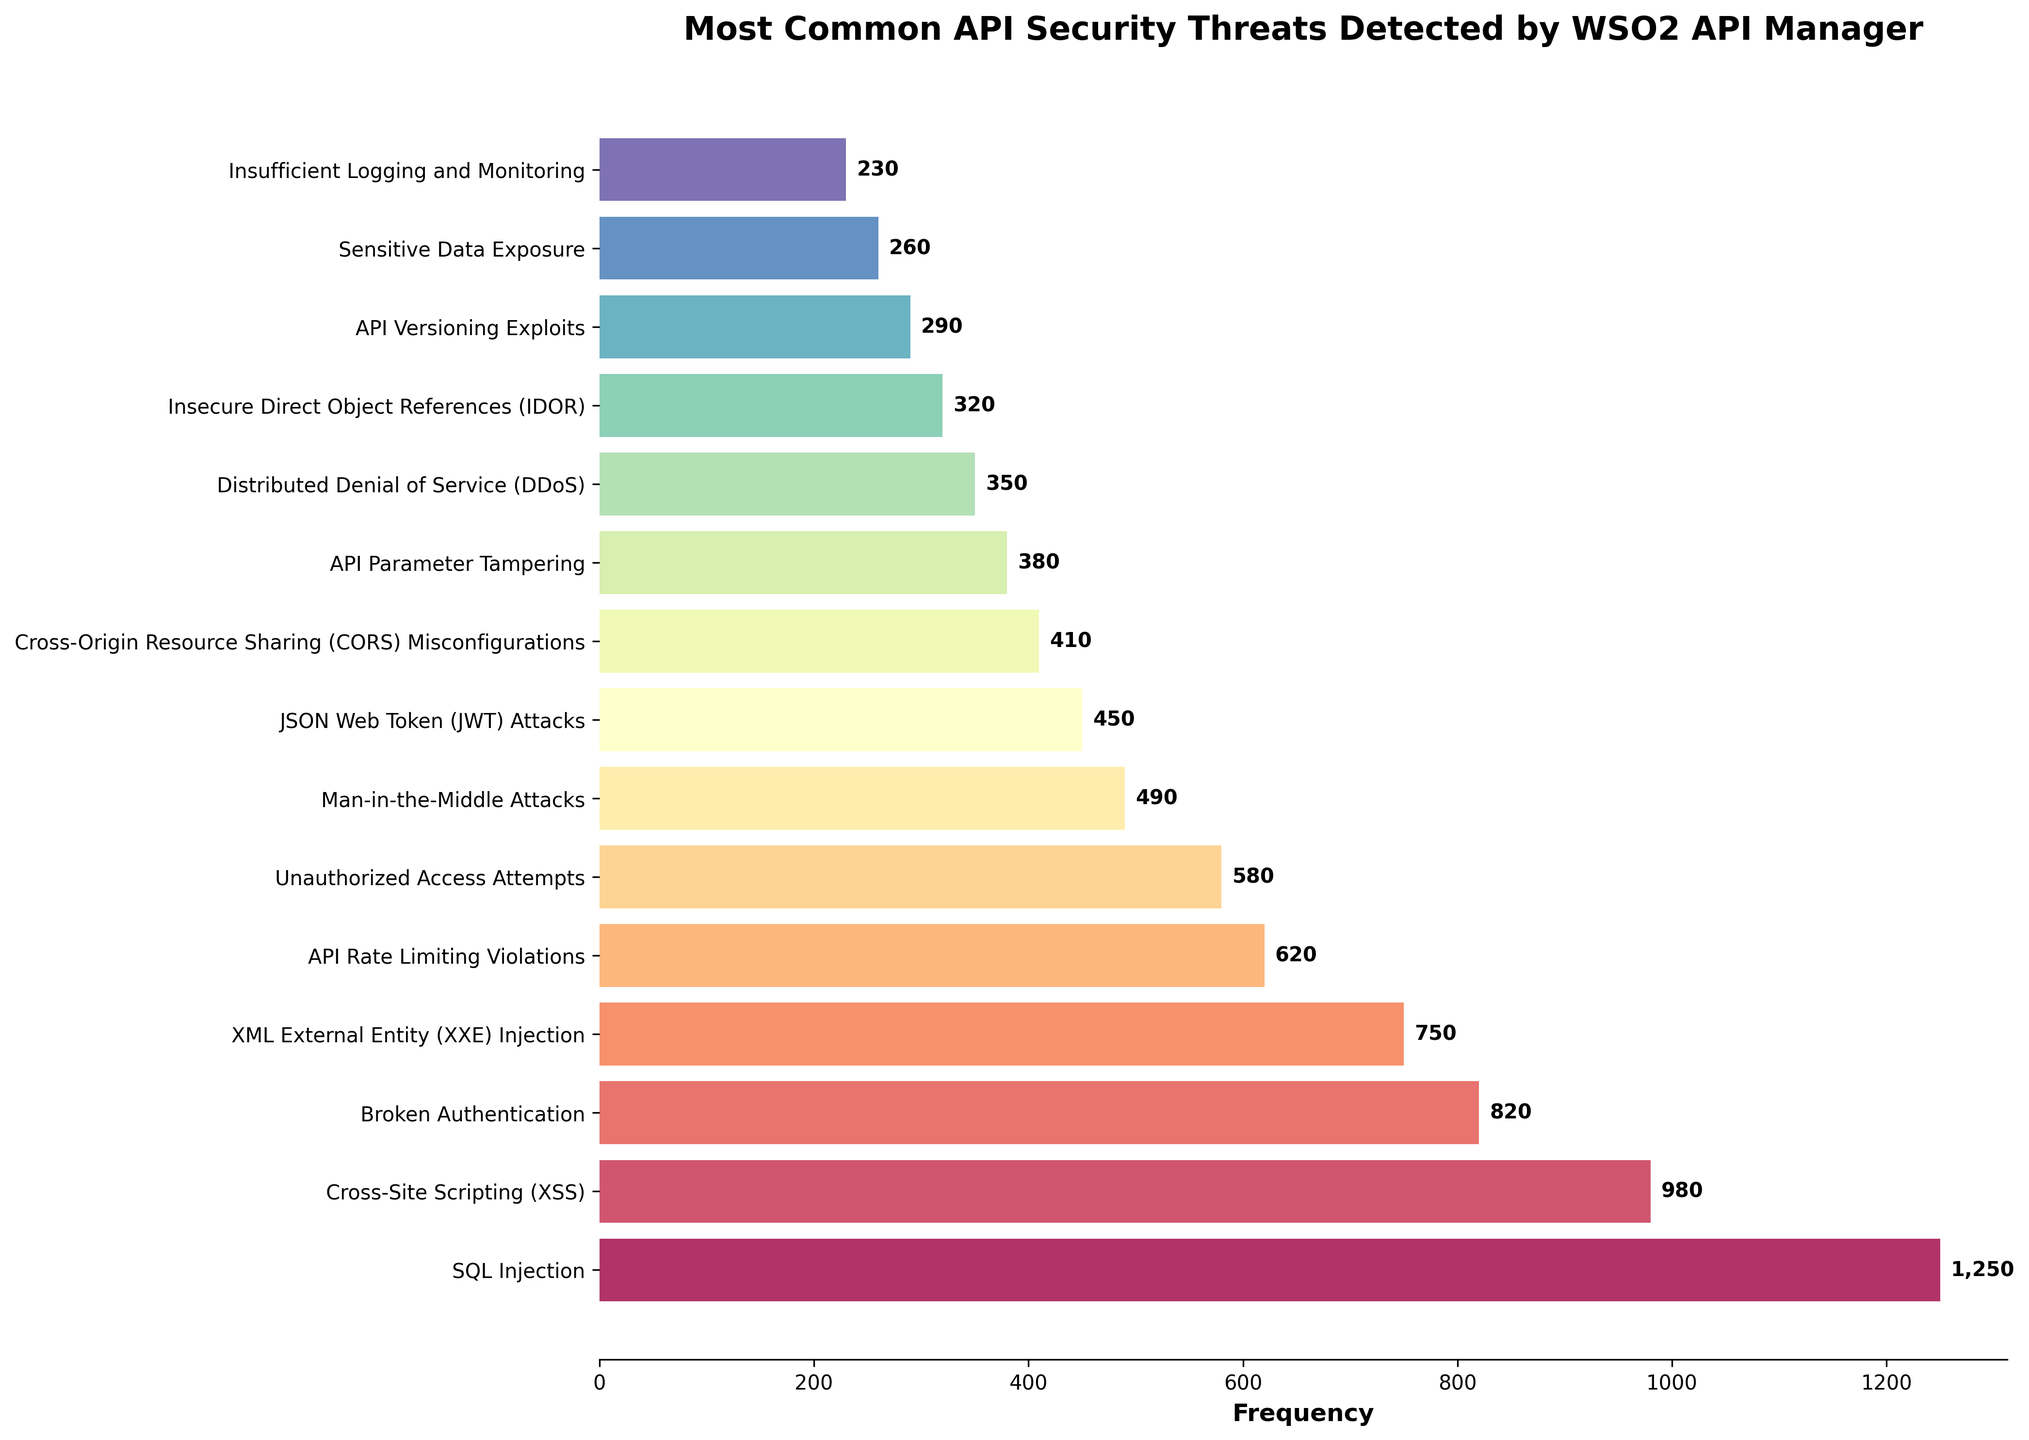What's the most common API security threat detected by WSO2 API Manager? The bar with the highest frequency value indicates the most common threat. In this case, SQL Injection has the highest frequency of 1250.
Answer: SQL Injection Which threat is more common: Cross-Site Scripting (XSS) or Man-in-the-Middle Attacks? Compare the frequencies of Cross-Site Scripting (980) and Man-in-the-Middle Attacks (490). Since 980 is greater than 490, Cross-Site Scripting is more common.
Answer: Cross-Site Scripting What is the combined frequency of Unauthorized Access Attempts and JSON Web Token (JWT) Attacks? Add the frequencies of Unauthorized Access Attempts (580) and JSON Web Token (JWT) Attacks (450). The sum is 580 + 450 = 1030.
Answer: 1030 Which threat has the lowest frequency according to the chart? The threat with the shortest bar represents the lowest frequency. Insufficient Logging and Monitoring has the lowest frequency at 230.
Answer: Insufficient Logging and Monitoring How much higher is the frequency of SQL Injection compared to API Rate Limiting Violations? Subtract the frequency of API Rate Limiting Violations (620) from the frequency of SQL Injection (1250). The difference is 1250 - 620 = 630.
Answer: 630 Order the following threats from highest to lowest frequency: API Versioning Exploits, XML External Entity (XXE) Injection, API Parameter Tampering. XML External Entity (XXE) Injection (750) > API Parameter Tampering (380) > API Versioning Exploits (290).
Answer: XML External Entity (XXE) Injection, API Parameter Tampering, API Versioning Exploits What is the average frequency of Cross-Origin Resource Sharing (CORS) Misconfigurations, Distributed Denial of Service (DDoS), and Sensitive Data Exposure? Sum the frequencies: 410 (CORS) + 350 (DDoS) + 260 (Sensitive Data Exposure). Then divide by 3: (410 + 350 + 260) / 3 = 1020 / 3 = 340.
Answer: 340 Are there more API Rate Limiting Violations or Broken Authentication incidents? Compare the frequencies: API Rate Limiting Violations (620) and Broken Authentication (820). 820 is greater than 620, so there are more Broken Authentication incidents.
Answer: Broken Authentication What visual pattern do you observe regarding the length of bars for different threats? The length of bars represents the frequency of each threat. Visually, SQL Injection has the longest bar, indicating it's the most common threat, while Insufficient Logging and Monitoring has the shortest bar, indicating it's the least common.
Answer: SQL Injection has the longest bar, Insufficient Logging and Monitoring has the shortest What is the total frequency of the top three most common threats? Identify the top three most common threats: SQL Injection (1250), Cross-Site Scripting (980), and Broken Authentication (820). Sum their frequencies: 1250 + 980 + 820 = 3050.
Answer: 3050 